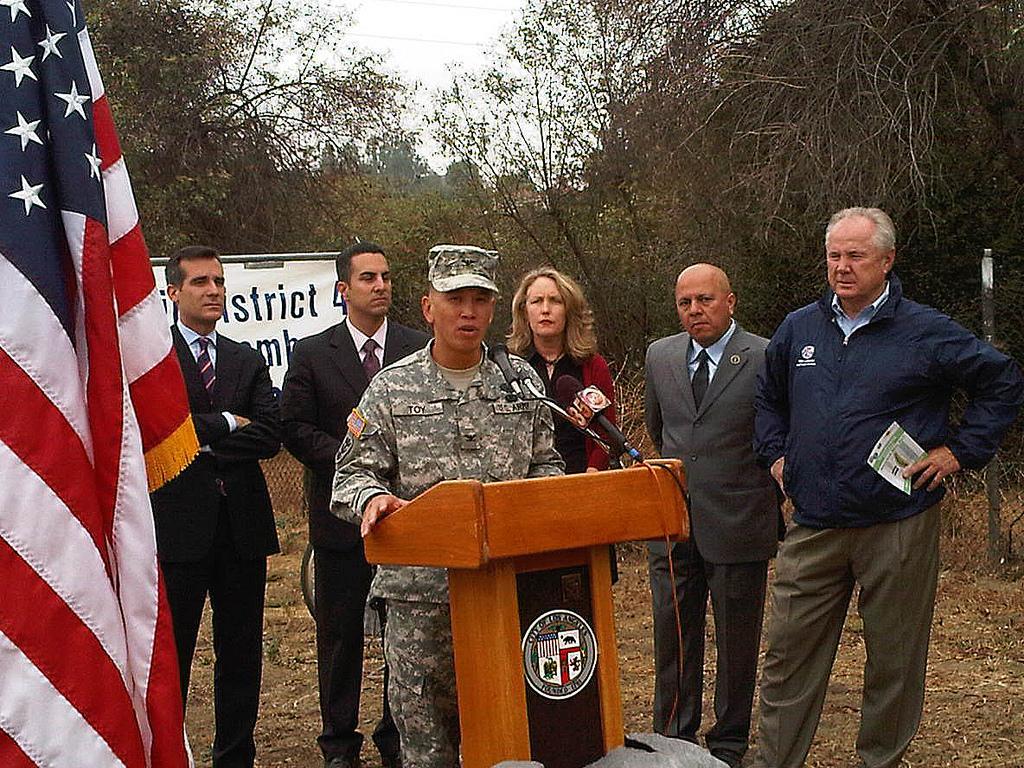Describe this image in one or two sentences. In this picture we can see a man standing at the podium and in front of him we can see mics, flag, stones and at the back of him we can see five people standing on the ground and in the background we can see a banner, fence, trees and the sky. 